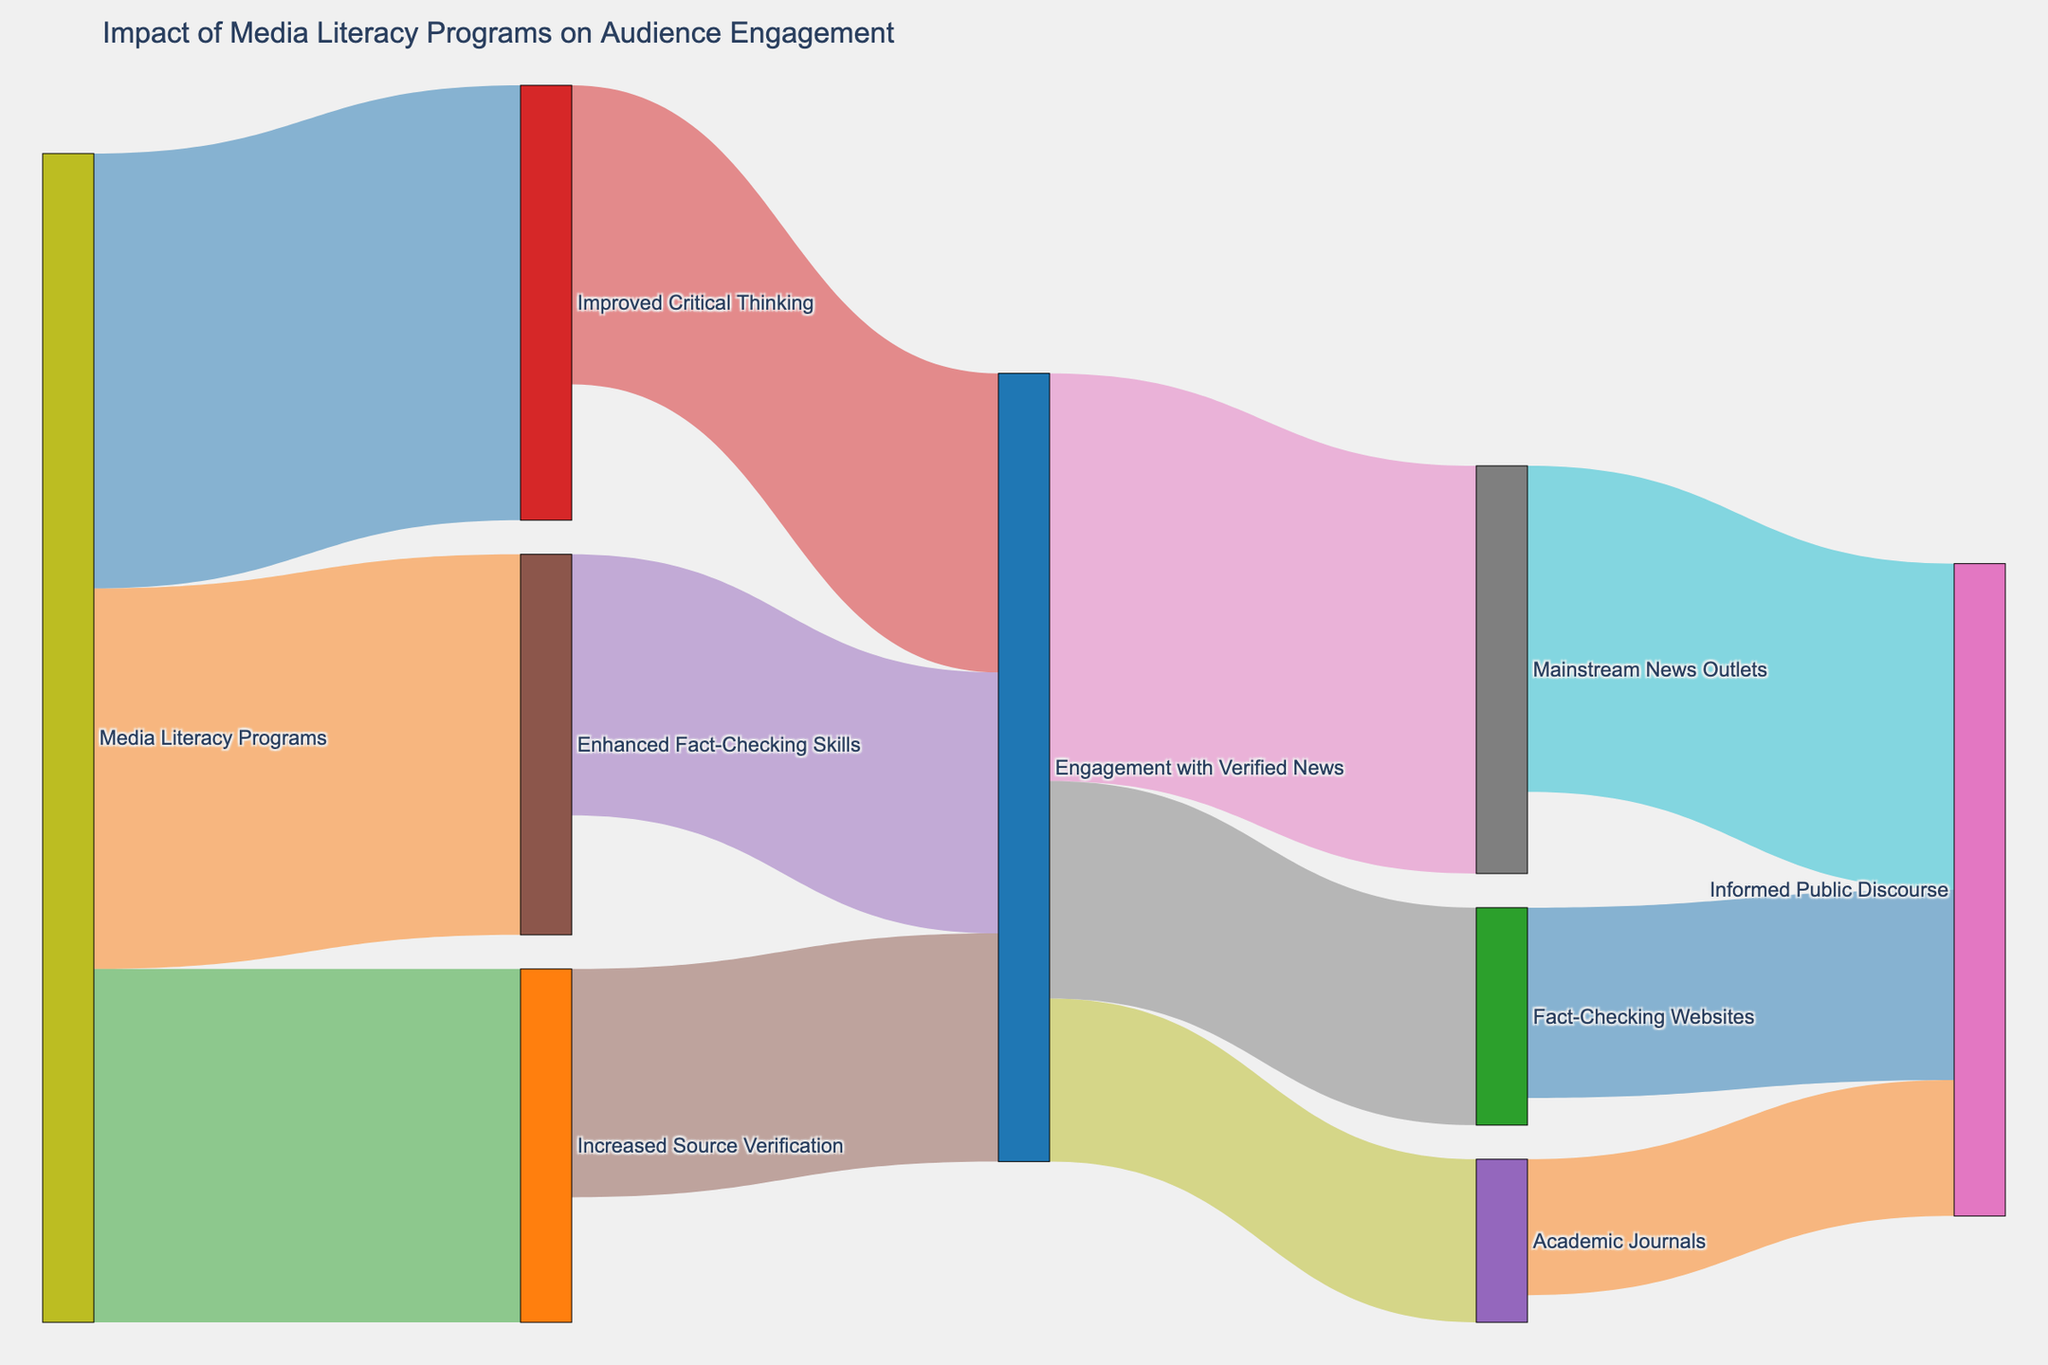What's the title of the Sankey diagram? The title of the diagram is located at the top of the figure. It indicates the main subject of the diagram, which is the impact of media literacy programs on audience engagement.
Answer: Impact of Media Literacy Programs on Audience Engagement How many nodes are in the Sankey diagram? Nodes represent different stages or elements in the diagram. Count all the unique nodes shown in the visual.
Answer: 12 What is the largest flow originating from "Media Literacy Programs" and where does it go? The values next to the connecting lines indicate the flow sizes. Identify the largest value originating from "Media Literacy Programs" and see which node it connects to.
Answer: Improved Critical Thinking, 8000 How many individuals engaged with mainstream news outlets after involvement with verified news, and how does this compare to engagement with academic journals? Find the values corresponding to the "Engagement with Verified News" node flowing into "Mainstream News Outlets" and "Academic Journals". Compare these values.
Answer: 7500 (Mainstream) vs. 3000 (Academic) What is the combined impact of "Fact-Checking Websites" and "Academic Journals" on informed public discourse? Identify the value flows from both "Fact-Checking Websites" and "Academic Journals" to "Informed Public Discourse". Add these values together to get the combined impact.
Answer: 3500 (Fact-Checking Websites) + 2500 (Academic Journals) = 6000 Which media literacy program skill has the lowest connection to "Engagement with Verified News"? Look at the skill sets originating from "Media Literacy Programs" and see their connection values to "Engagement with Verified News". Identify the lowest value among them.
Answer: Increased Source Verification, 4200 What's the total audience engagement with verified news after being influenced by media literacy programs? Sum up all the values that flow into "Engagement with Verified News" from the skills improved by media literacy programs.
Answer: 5500 + 4800 + 4200 = 14500 How does the value from "Engaged with Verified News" to "Fact-Checking Websites" compare with that to "Mainstream News Outlets"? Identify the values of the flows from "Engaged with Verified News" to "Fact-Checking Websites" and "Mainstream News Outlets". Compare these values to determine which is larger.
Answer: 4000 (Fact-Checking Websites) vs 7500 (Mainstream News Outlets) What is the overall impact on informed public discourse considering all flows from engagement with verified news sources? Sum up the values of all flows from "Engagement with Verified News" to entities contributing to informed public discourse.
Answer: 6000 (Mainstream News) + 3500 (Fact-Checking Websites) + 2500 (Academic Journals) = 12000 Which aspect of critical thinking enhancement contributes the most to informed public discourse? Trace the flows starting from "Improved Critical Thinking" down to "Informed Public Discourse" and compare to see which intermediary contributes the most.
Answer: Mainstream News Outlets, 6000 